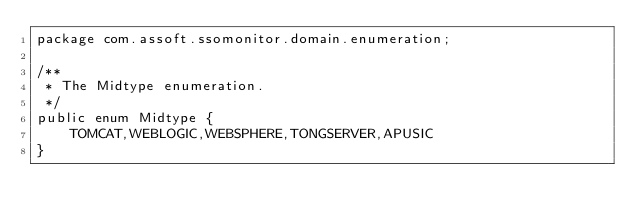<code> <loc_0><loc_0><loc_500><loc_500><_Java_>package com.assoft.ssomonitor.domain.enumeration;

/**
 * The Midtype enumeration.
 */
public enum Midtype {
    TOMCAT,WEBLOGIC,WEBSPHERE,TONGSERVER,APUSIC
}
</code> 